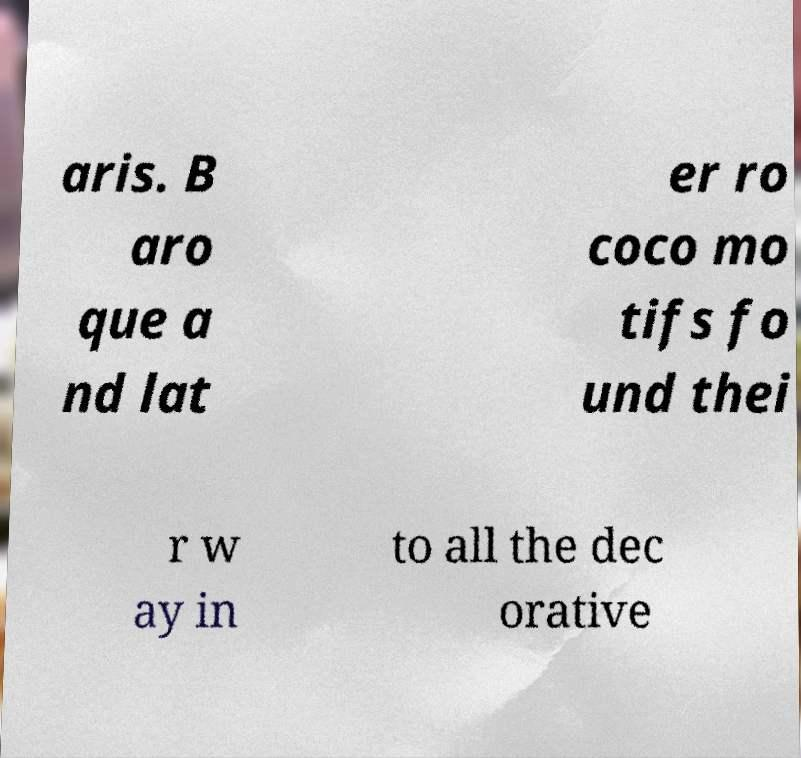Please read and relay the text visible in this image. What does it say? aris. B aro que a nd lat er ro coco mo tifs fo und thei r w ay in to all the dec orative 